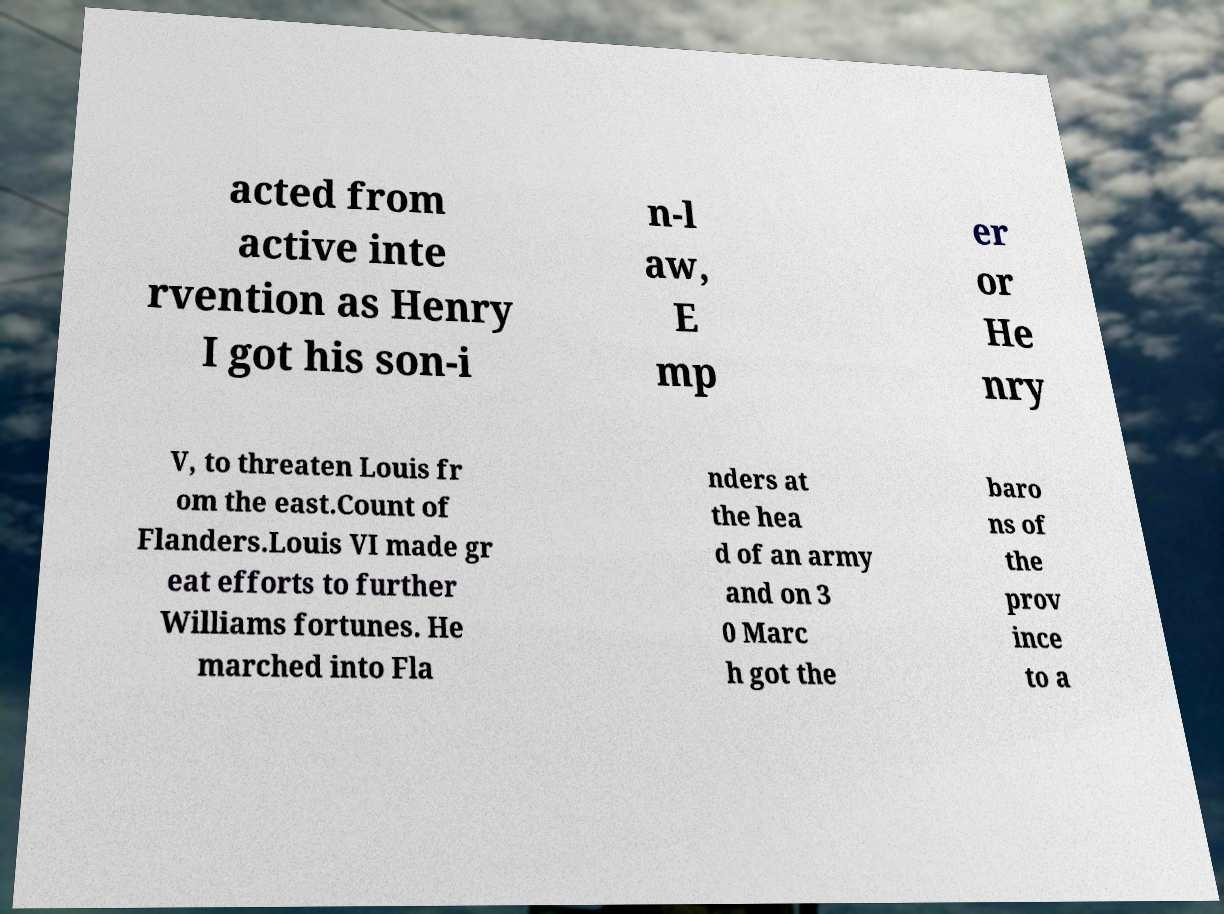I need the written content from this picture converted into text. Can you do that? acted from active inte rvention as Henry I got his son-i n-l aw, E mp er or He nry V, to threaten Louis fr om the east.Count of Flanders.Louis VI made gr eat efforts to further Williams fortunes. He marched into Fla nders at the hea d of an army and on 3 0 Marc h got the baro ns of the prov ince to a 